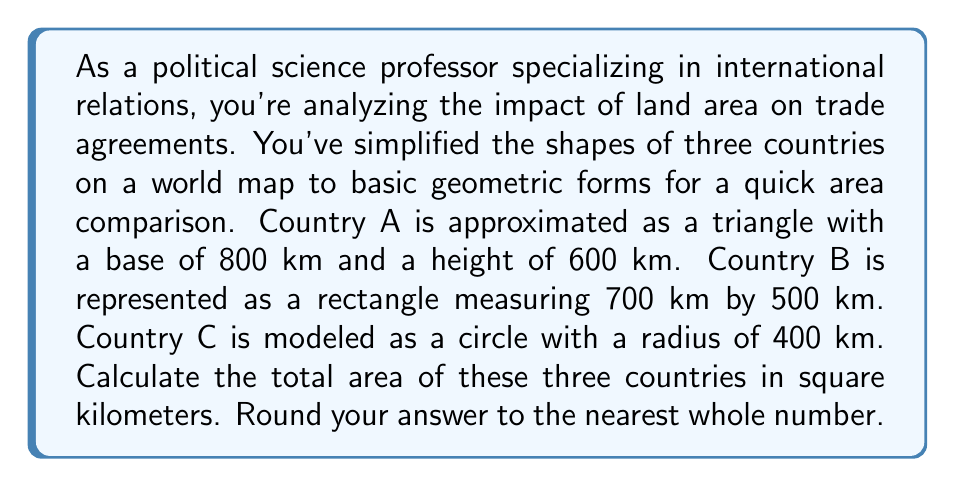Give your solution to this math problem. To solve this problem, we need to calculate the area of each country separately and then sum them up:

1. Country A (Triangle):
   The area of a triangle is given by the formula: $A = \frac{1}{2} \times base \times height$
   $$A_A = \frac{1}{2} \times 800 \times 600 = 240,000 \text{ km}^2$$

2. Country B (Rectangle):
   The area of a rectangle is given by the formula: $A = length \times width$
   $$A_B = 700 \times 500 = 350,000 \text{ km}^2$$

3. Country C (Circle):
   The area of a circle is given by the formula: $A = \pi r^2$
   $$A_C = \pi \times 400^2 = 502,654.82... \text{ km}^2$$

Now, we sum up the areas of all three countries:

$$\text{Total Area} = A_A + A_B + A_C$$
$$= 240,000 + 350,000 + 502,654.82...$$
$$= 1,092,654.82... \text{ km}^2$$

Rounding to the nearest whole number:
$$\text{Total Area} \approx 1,092,655 \text{ km}^2$$
Answer: 1,092,655 km² 